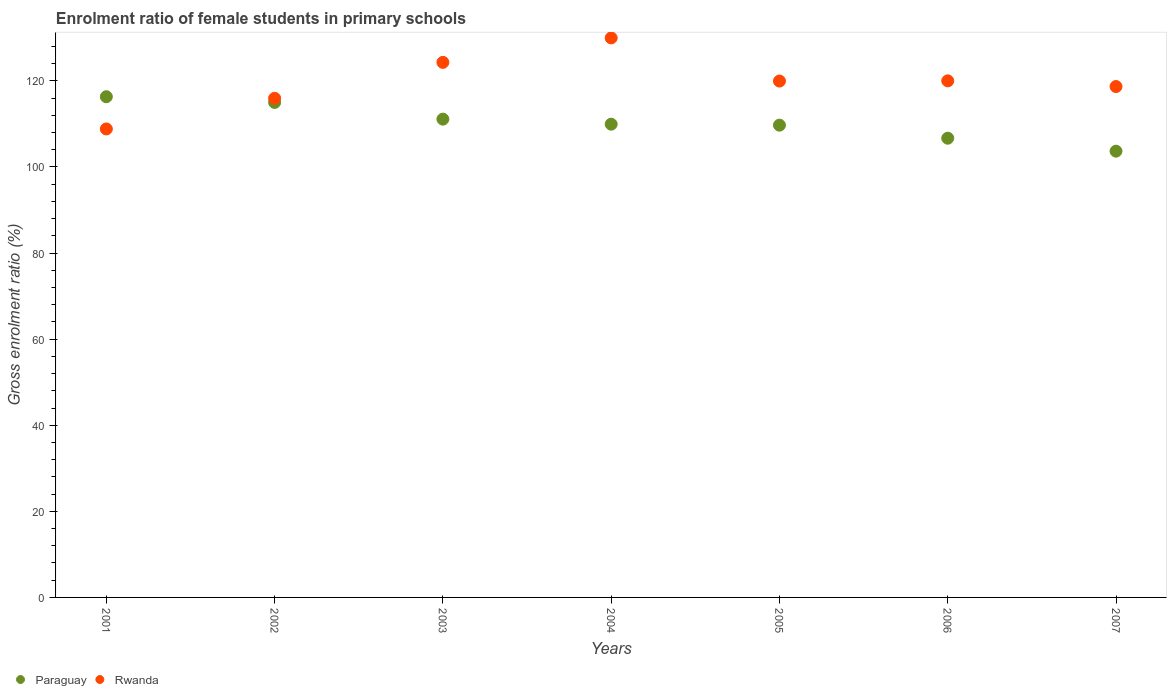Is the number of dotlines equal to the number of legend labels?
Give a very brief answer. Yes. What is the enrolment ratio of female students in primary schools in Paraguay in 2003?
Ensure brevity in your answer.  111.11. Across all years, what is the maximum enrolment ratio of female students in primary schools in Paraguay?
Your response must be concise. 116.31. Across all years, what is the minimum enrolment ratio of female students in primary schools in Paraguay?
Offer a very short reply. 103.66. In which year was the enrolment ratio of female students in primary schools in Rwanda maximum?
Provide a succinct answer. 2004. In which year was the enrolment ratio of female students in primary schools in Rwanda minimum?
Offer a very short reply. 2001. What is the total enrolment ratio of female students in primary schools in Paraguay in the graph?
Provide a short and direct response. 772.37. What is the difference between the enrolment ratio of female students in primary schools in Paraguay in 2004 and that in 2005?
Offer a very short reply. 0.23. What is the difference between the enrolment ratio of female students in primary schools in Rwanda in 2006 and the enrolment ratio of female students in primary schools in Paraguay in 2004?
Offer a terse response. 10.07. What is the average enrolment ratio of female students in primary schools in Paraguay per year?
Keep it short and to the point. 110.34. In the year 2002, what is the difference between the enrolment ratio of female students in primary schools in Rwanda and enrolment ratio of female students in primary schools in Paraguay?
Offer a very short reply. 0.96. What is the ratio of the enrolment ratio of female students in primary schools in Rwanda in 2001 to that in 2004?
Your response must be concise. 0.84. Is the enrolment ratio of female students in primary schools in Paraguay in 2003 less than that in 2006?
Provide a short and direct response. No. What is the difference between the highest and the second highest enrolment ratio of female students in primary schools in Paraguay?
Your answer should be compact. 1.33. What is the difference between the highest and the lowest enrolment ratio of female students in primary schools in Rwanda?
Ensure brevity in your answer.  21.15. Is the sum of the enrolment ratio of female students in primary schools in Rwanda in 2001 and 2007 greater than the maximum enrolment ratio of female students in primary schools in Paraguay across all years?
Give a very brief answer. Yes. Does the enrolment ratio of female students in primary schools in Paraguay monotonically increase over the years?
Give a very brief answer. No. Is the enrolment ratio of female students in primary schools in Paraguay strictly less than the enrolment ratio of female students in primary schools in Rwanda over the years?
Give a very brief answer. No. How many dotlines are there?
Your answer should be compact. 2. How many years are there in the graph?
Give a very brief answer. 7. Are the values on the major ticks of Y-axis written in scientific E-notation?
Keep it short and to the point. No. Does the graph contain grids?
Make the answer very short. No. Where does the legend appear in the graph?
Your response must be concise. Bottom left. How many legend labels are there?
Give a very brief answer. 2. How are the legend labels stacked?
Provide a short and direct response. Horizontal. What is the title of the graph?
Provide a succinct answer. Enrolment ratio of female students in primary schools. What is the Gross enrolment ratio (%) of Paraguay in 2001?
Keep it short and to the point. 116.31. What is the Gross enrolment ratio (%) of Rwanda in 2001?
Provide a short and direct response. 108.82. What is the Gross enrolment ratio (%) in Paraguay in 2002?
Your answer should be compact. 114.98. What is the Gross enrolment ratio (%) of Rwanda in 2002?
Provide a short and direct response. 115.94. What is the Gross enrolment ratio (%) in Paraguay in 2003?
Offer a very short reply. 111.11. What is the Gross enrolment ratio (%) in Rwanda in 2003?
Give a very brief answer. 124.29. What is the Gross enrolment ratio (%) in Paraguay in 2004?
Provide a succinct answer. 109.93. What is the Gross enrolment ratio (%) of Rwanda in 2004?
Make the answer very short. 129.97. What is the Gross enrolment ratio (%) of Paraguay in 2005?
Offer a terse response. 109.7. What is the Gross enrolment ratio (%) in Rwanda in 2005?
Your answer should be very brief. 119.95. What is the Gross enrolment ratio (%) in Paraguay in 2006?
Ensure brevity in your answer.  106.68. What is the Gross enrolment ratio (%) in Rwanda in 2006?
Your answer should be compact. 120. What is the Gross enrolment ratio (%) of Paraguay in 2007?
Ensure brevity in your answer.  103.66. What is the Gross enrolment ratio (%) in Rwanda in 2007?
Your answer should be very brief. 118.68. Across all years, what is the maximum Gross enrolment ratio (%) of Paraguay?
Your response must be concise. 116.31. Across all years, what is the maximum Gross enrolment ratio (%) in Rwanda?
Provide a succinct answer. 129.97. Across all years, what is the minimum Gross enrolment ratio (%) in Paraguay?
Your response must be concise. 103.66. Across all years, what is the minimum Gross enrolment ratio (%) in Rwanda?
Provide a succinct answer. 108.82. What is the total Gross enrolment ratio (%) of Paraguay in the graph?
Provide a short and direct response. 772.37. What is the total Gross enrolment ratio (%) of Rwanda in the graph?
Give a very brief answer. 837.66. What is the difference between the Gross enrolment ratio (%) of Paraguay in 2001 and that in 2002?
Keep it short and to the point. 1.33. What is the difference between the Gross enrolment ratio (%) of Rwanda in 2001 and that in 2002?
Offer a terse response. -7.12. What is the difference between the Gross enrolment ratio (%) in Paraguay in 2001 and that in 2003?
Give a very brief answer. 5.2. What is the difference between the Gross enrolment ratio (%) in Rwanda in 2001 and that in 2003?
Your answer should be very brief. -15.47. What is the difference between the Gross enrolment ratio (%) in Paraguay in 2001 and that in 2004?
Offer a terse response. 6.38. What is the difference between the Gross enrolment ratio (%) of Rwanda in 2001 and that in 2004?
Make the answer very short. -21.15. What is the difference between the Gross enrolment ratio (%) in Paraguay in 2001 and that in 2005?
Your answer should be very brief. 6.61. What is the difference between the Gross enrolment ratio (%) in Rwanda in 2001 and that in 2005?
Ensure brevity in your answer.  -11.13. What is the difference between the Gross enrolment ratio (%) of Paraguay in 2001 and that in 2006?
Make the answer very short. 9.63. What is the difference between the Gross enrolment ratio (%) of Rwanda in 2001 and that in 2006?
Offer a terse response. -11.18. What is the difference between the Gross enrolment ratio (%) in Paraguay in 2001 and that in 2007?
Provide a short and direct response. 12.65. What is the difference between the Gross enrolment ratio (%) of Rwanda in 2001 and that in 2007?
Provide a short and direct response. -9.85. What is the difference between the Gross enrolment ratio (%) of Paraguay in 2002 and that in 2003?
Offer a very short reply. 3.87. What is the difference between the Gross enrolment ratio (%) in Rwanda in 2002 and that in 2003?
Ensure brevity in your answer.  -8.35. What is the difference between the Gross enrolment ratio (%) in Paraguay in 2002 and that in 2004?
Your response must be concise. 5.05. What is the difference between the Gross enrolment ratio (%) in Rwanda in 2002 and that in 2004?
Ensure brevity in your answer.  -14.03. What is the difference between the Gross enrolment ratio (%) of Paraguay in 2002 and that in 2005?
Give a very brief answer. 5.27. What is the difference between the Gross enrolment ratio (%) in Rwanda in 2002 and that in 2005?
Your answer should be very brief. -4.01. What is the difference between the Gross enrolment ratio (%) in Paraguay in 2002 and that in 2006?
Ensure brevity in your answer.  8.3. What is the difference between the Gross enrolment ratio (%) of Rwanda in 2002 and that in 2006?
Provide a succinct answer. -4.06. What is the difference between the Gross enrolment ratio (%) of Paraguay in 2002 and that in 2007?
Give a very brief answer. 11.31. What is the difference between the Gross enrolment ratio (%) of Rwanda in 2002 and that in 2007?
Offer a terse response. -2.74. What is the difference between the Gross enrolment ratio (%) of Paraguay in 2003 and that in 2004?
Offer a terse response. 1.17. What is the difference between the Gross enrolment ratio (%) in Rwanda in 2003 and that in 2004?
Provide a succinct answer. -5.68. What is the difference between the Gross enrolment ratio (%) in Paraguay in 2003 and that in 2005?
Keep it short and to the point. 1.4. What is the difference between the Gross enrolment ratio (%) in Rwanda in 2003 and that in 2005?
Keep it short and to the point. 4.34. What is the difference between the Gross enrolment ratio (%) in Paraguay in 2003 and that in 2006?
Give a very brief answer. 4.43. What is the difference between the Gross enrolment ratio (%) in Rwanda in 2003 and that in 2006?
Your answer should be compact. 4.29. What is the difference between the Gross enrolment ratio (%) of Paraguay in 2003 and that in 2007?
Your response must be concise. 7.44. What is the difference between the Gross enrolment ratio (%) in Rwanda in 2003 and that in 2007?
Your answer should be compact. 5.62. What is the difference between the Gross enrolment ratio (%) in Paraguay in 2004 and that in 2005?
Provide a short and direct response. 0.23. What is the difference between the Gross enrolment ratio (%) in Rwanda in 2004 and that in 2005?
Your response must be concise. 10.02. What is the difference between the Gross enrolment ratio (%) of Paraguay in 2004 and that in 2006?
Make the answer very short. 3.26. What is the difference between the Gross enrolment ratio (%) of Rwanda in 2004 and that in 2006?
Offer a very short reply. 9.97. What is the difference between the Gross enrolment ratio (%) in Paraguay in 2004 and that in 2007?
Your answer should be compact. 6.27. What is the difference between the Gross enrolment ratio (%) in Rwanda in 2004 and that in 2007?
Offer a terse response. 11.3. What is the difference between the Gross enrolment ratio (%) in Paraguay in 2005 and that in 2006?
Keep it short and to the point. 3.03. What is the difference between the Gross enrolment ratio (%) in Rwanda in 2005 and that in 2006?
Offer a very short reply. -0.05. What is the difference between the Gross enrolment ratio (%) in Paraguay in 2005 and that in 2007?
Give a very brief answer. 6.04. What is the difference between the Gross enrolment ratio (%) of Rwanda in 2005 and that in 2007?
Ensure brevity in your answer.  1.27. What is the difference between the Gross enrolment ratio (%) of Paraguay in 2006 and that in 2007?
Keep it short and to the point. 3.01. What is the difference between the Gross enrolment ratio (%) in Rwanda in 2006 and that in 2007?
Make the answer very short. 1.32. What is the difference between the Gross enrolment ratio (%) of Paraguay in 2001 and the Gross enrolment ratio (%) of Rwanda in 2002?
Offer a terse response. 0.37. What is the difference between the Gross enrolment ratio (%) of Paraguay in 2001 and the Gross enrolment ratio (%) of Rwanda in 2003?
Your answer should be compact. -7.98. What is the difference between the Gross enrolment ratio (%) in Paraguay in 2001 and the Gross enrolment ratio (%) in Rwanda in 2004?
Offer a terse response. -13.66. What is the difference between the Gross enrolment ratio (%) of Paraguay in 2001 and the Gross enrolment ratio (%) of Rwanda in 2005?
Make the answer very short. -3.64. What is the difference between the Gross enrolment ratio (%) in Paraguay in 2001 and the Gross enrolment ratio (%) in Rwanda in 2006?
Make the answer very short. -3.69. What is the difference between the Gross enrolment ratio (%) in Paraguay in 2001 and the Gross enrolment ratio (%) in Rwanda in 2007?
Ensure brevity in your answer.  -2.37. What is the difference between the Gross enrolment ratio (%) in Paraguay in 2002 and the Gross enrolment ratio (%) in Rwanda in 2003?
Your answer should be very brief. -9.31. What is the difference between the Gross enrolment ratio (%) in Paraguay in 2002 and the Gross enrolment ratio (%) in Rwanda in 2004?
Your answer should be very brief. -14.99. What is the difference between the Gross enrolment ratio (%) in Paraguay in 2002 and the Gross enrolment ratio (%) in Rwanda in 2005?
Give a very brief answer. -4.97. What is the difference between the Gross enrolment ratio (%) in Paraguay in 2002 and the Gross enrolment ratio (%) in Rwanda in 2006?
Provide a succinct answer. -5.02. What is the difference between the Gross enrolment ratio (%) of Paraguay in 2002 and the Gross enrolment ratio (%) of Rwanda in 2007?
Offer a terse response. -3.7. What is the difference between the Gross enrolment ratio (%) in Paraguay in 2003 and the Gross enrolment ratio (%) in Rwanda in 2004?
Your answer should be compact. -18.87. What is the difference between the Gross enrolment ratio (%) of Paraguay in 2003 and the Gross enrolment ratio (%) of Rwanda in 2005?
Your response must be concise. -8.84. What is the difference between the Gross enrolment ratio (%) in Paraguay in 2003 and the Gross enrolment ratio (%) in Rwanda in 2006?
Ensure brevity in your answer.  -8.89. What is the difference between the Gross enrolment ratio (%) in Paraguay in 2003 and the Gross enrolment ratio (%) in Rwanda in 2007?
Provide a short and direct response. -7.57. What is the difference between the Gross enrolment ratio (%) of Paraguay in 2004 and the Gross enrolment ratio (%) of Rwanda in 2005?
Offer a very short reply. -10.02. What is the difference between the Gross enrolment ratio (%) of Paraguay in 2004 and the Gross enrolment ratio (%) of Rwanda in 2006?
Provide a succinct answer. -10.07. What is the difference between the Gross enrolment ratio (%) in Paraguay in 2004 and the Gross enrolment ratio (%) in Rwanda in 2007?
Provide a short and direct response. -8.74. What is the difference between the Gross enrolment ratio (%) in Paraguay in 2005 and the Gross enrolment ratio (%) in Rwanda in 2006?
Ensure brevity in your answer.  -10.3. What is the difference between the Gross enrolment ratio (%) in Paraguay in 2005 and the Gross enrolment ratio (%) in Rwanda in 2007?
Offer a very short reply. -8.97. What is the difference between the Gross enrolment ratio (%) in Paraguay in 2006 and the Gross enrolment ratio (%) in Rwanda in 2007?
Give a very brief answer. -12. What is the average Gross enrolment ratio (%) of Paraguay per year?
Your answer should be compact. 110.34. What is the average Gross enrolment ratio (%) in Rwanda per year?
Offer a very short reply. 119.67. In the year 2001, what is the difference between the Gross enrolment ratio (%) of Paraguay and Gross enrolment ratio (%) of Rwanda?
Give a very brief answer. 7.49. In the year 2002, what is the difference between the Gross enrolment ratio (%) of Paraguay and Gross enrolment ratio (%) of Rwanda?
Keep it short and to the point. -0.96. In the year 2003, what is the difference between the Gross enrolment ratio (%) of Paraguay and Gross enrolment ratio (%) of Rwanda?
Make the answer very short. -13.19. In the year 2004, what is the difference between the Gross enrolment ratio (%) in Paraguay and Gross enrolment ratio (%) in Rwanda?
Provide a short and direct response. -20.04. In the year 2005, what is the difference between the Gross enrolment ratio (%) in Paraguay and Gross enrolment ratio (%) in Rwanda?
Your response must be concise. -10.25. In the year 2006, what is the difference between the Gross enrolment ratio (%) in Paraguay and Gross enrolment ratio (%) in Rwanda?
Ensure brevity in your answer.  -13.32. In the year 2007, what is the difference between the Gross enrolment ratio (%) of Paraguay and Gross enrolment ratio (%) of Rwanda?
Provide a short and direct response. -15.01. What is the ratio of the Gross enrolment ratio (%) in Paraguay in 2001 to that in 2002?
Make the answer very short. 1.01. What is the ratio of the Gross enrolment ratio (%) in Rwanda in 2001 to that in 2002?
Keep it short and to the point. 0.94. What is the ratio of the Gross enrolment ratio (%) of Paraguay in 2001 to that in 2003?
Offer a terse response. 1.05. What is the ratio of the Gross enrolment ratio (%) in Rwanda in 2001 to that in 2003?
Keep it short and to the point. 0.88. What is the ratio of the Gross enrolment ratio (%) of Paraguay in 2001 to that in 2004?
Provide a short and direct response. 1.06. What is the ratio of the Gross enrolment ratio (%) in Rwanda in 2001 to that in 2004?
Your response must be concise. 0.84. What is the ratio of the Gross enrolment ratio (%) in Paraguay in 2001 to that in 2005?
Offer a terse response. 1.06. What is the ratio of the Gross enrolment ratio (%) of Rwanda in 2001 to that in 2005?
Provide a succinct answer. 0.91. What is the ratio of the Gross enrolment ratio (%) of Paraguay in 2001 to that in 2006?
Your answer should be compact. 1.09. What is the ratio of the Gross enrolment ratio (%) of Rwanda in 2001 to that in 2006?
Your response must be concise. 0.91. What is the ratio of the Gross enrolment ratio (%) in Paraguay in 2001 to that in 2007?
Your response must be concise. 1.12. What is the ratio of the Gross enrolment ratio (%) in Rwanda in 2001 to that in 2007?
Keep it short and to the point. 0.92. What is the ratio of the Gross enrolment ratio (%) of Paraguay in 2002 to that in 2003?
Keep it short and to the point. 1.03. What is the ratio of the Gross enrolment ratio (%) in Rwanda in 2002 to that in 2003?
Your response must be concise. 0.93. What is the ratio of the Gross enrolment ratio (%) of Paraguay in 2002 to that in 2004?
Ensure brevity in your answer.  1.05. What is the ratio of the Gross enrolment ratio (%) of Rwanda in 2002 to that in 2004?
Ensure brevity in your answer.  0.89. What is the ratio of the Gross enrolment ratio (%) of Paraguay in 2002 to that in 2005?
Make the answer very short. 1.05. What is the ratio of the Gross enrolment ratio (%) in Rwanda in 2002 to that in 2005?
Offer a very short reply. 0.97. What is the ratio of the Gross enrolment ratio (%) of Paraguay in 2002 to that in 2006?
Your answer should be very brief. 1.08. What is the ratio of the Gross enrolment ratio (%) of Rwanda in 2002 to that in 2006?
Your response must be concise. 0.97. What is the ratio of the Gross enrolment ratio (%) in Paraguay in 2002 to that in 2007?
Keep it short and to the point. 1.11. What is the ratio of the Gross enrolment ratio (%) of Paraguay in 2003 to that in 2004?
Your response must be concise. 1.01. What is the ratio of the Gross enrolment ratio (%) in Rwanda in 2003 to that in 2004?
Offer a very short reply. 0.96. What is the ratio of the Gross enrolment ratio (%) of Paraguay in 2003 to that in 2005?
Give a very brief answer. 1.01. What is the ratio of the Gross enrolment ratio (%) of Rwanda in 2003 to that in 2005?
Your answer should be compact. 1.04. What is the ratio of the Gross enrolment ratio (%) of Paraguay in 2003 to that in 2006?
Provide a succinct answer. 1.04. What is the ratio of the Gross enrolment ratio (%) in Rwanda in 2003 to that in 2006?
Ensure brevity in your answer.  1.04. What is the ratio of the Gross enrolment ratio (%) of Paraguay in 2003 to that in 2007?
Your response must be concise. 1.07. What is the ratio of the Gross enrolment ratio (%) in Rwanda in 2003 to that in 2007?
Offer a very short reply. 1.05. What is the ratio of the Gross enrolment ratio (%) of Paraguay in 2004 to that in 2005?
Provide a succinct answer. 1. What is the ratio of the Gross enrolment ratio (%) of Rwanda in 2004 to that in 2005?
Provide a short and direct response. 1.08. What is the ratio of the Gross enrolment ratio (%) in Paraguay in 2004 to that in 2006?
Your answer should be compact. 1.03. What is the ratio of the Gross enrolment ratio (%) of Rwanda in 2004 to that in 2006?
Ensure brevity in your answer.  1.08. What is the ratio of the Gross enrolment ratio (%) of Paraguay in 2004 to that in 2007?
Your answer should be compact. 1.06. What is the ratio of the Gross enrolment ratio (%) in Rwanda in 2004 to that in 2007?
Your answer should be very brief. 1.1. What is the ratio of the Gross enrolment ratio (%) of Paraguay in 2005 to that in 2006?
Ensure brevity in your answer.  1.03. What is the ratio of the Gross enrolment ratio (%) of Paraguay in 2005 to that in 2007?
Make the answer very short. 1.06. What is the ratio of the Gross enrolment ratio (%) of Rwanda in 2005 to that in 2007?
Provide a short and direct response. 1.01. What is the ratio of the Gross enrolment ratio (%) of Rwanda in 2006 to that in 2007?
Your response must be concise. 1.01. What is the difference between the highest and the second highest Gross enrolment ratio (%) of Paraguay?
Your answer should be very brief. 1.33. What is the difference between the highest and the second highest Gross enrolment ratio (%) of Rwanda?
Provide a short and direct response. 5.68. What is the difference between the highest and the lowest Gross enrolment ratio (%) of Paraguay?
Keep it short and to the point. 12.65. What is the difference between the highest and the lowest Gross enrolment ratio (%) of Rwanda?
Your answer should be compact. 21.15. 